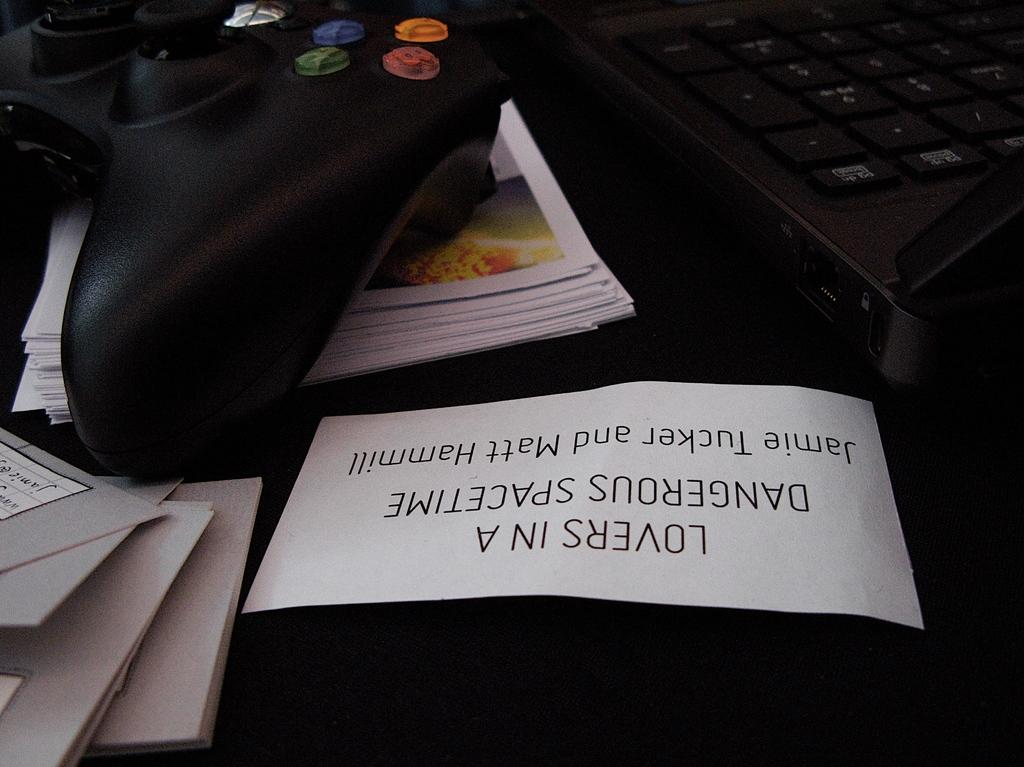<image>
Offer a succinct explanation of the picture presented. White label saying "Lovers In A Dangerous Spacetime" next to a controller. 